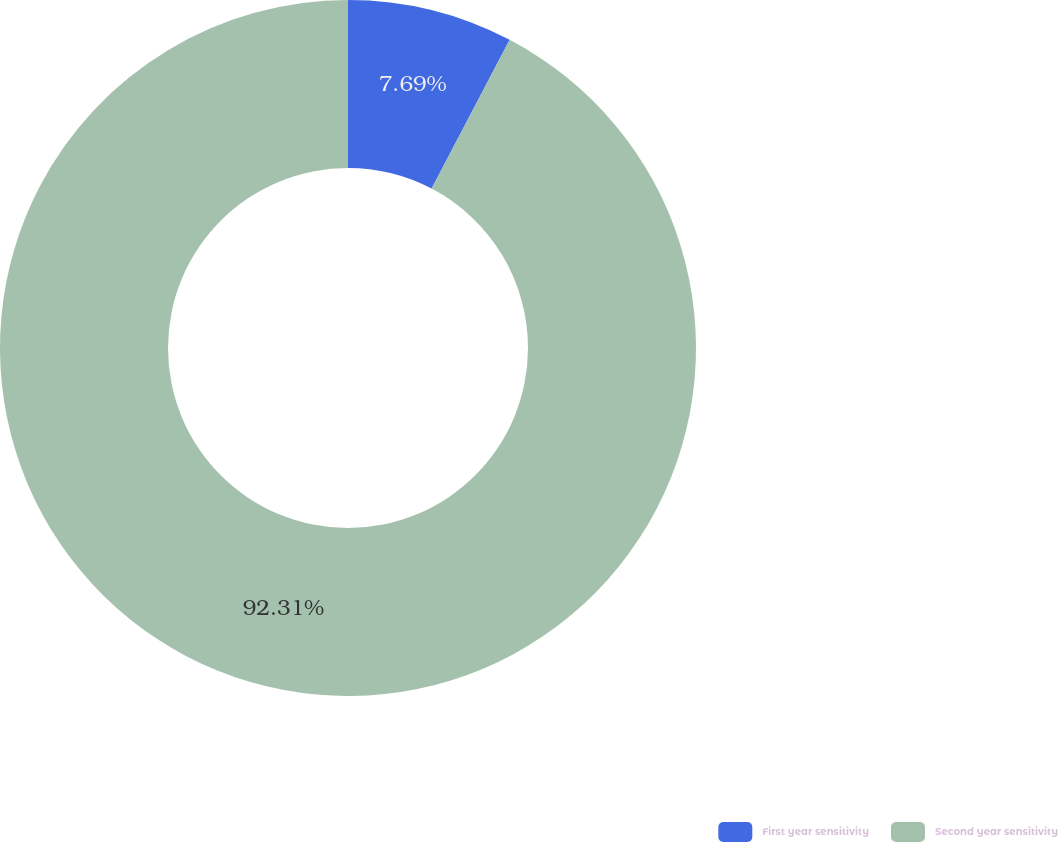<chart> <loc_0><loc_0><loc_500><loc_500><pie_chart><fcel>First year sensitivity<fcel>Second year sensitivity<nl><fcel>7.69%<fcel>92.31%<nl></chart> 